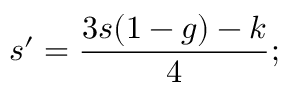Convert formula to latex. <formula><loc_0><loc_0><loc_500><loc_500>s ^ { \prime } = \frac { 3 s ( 1 - g ) - k } { 4 } ; \,</formula> 